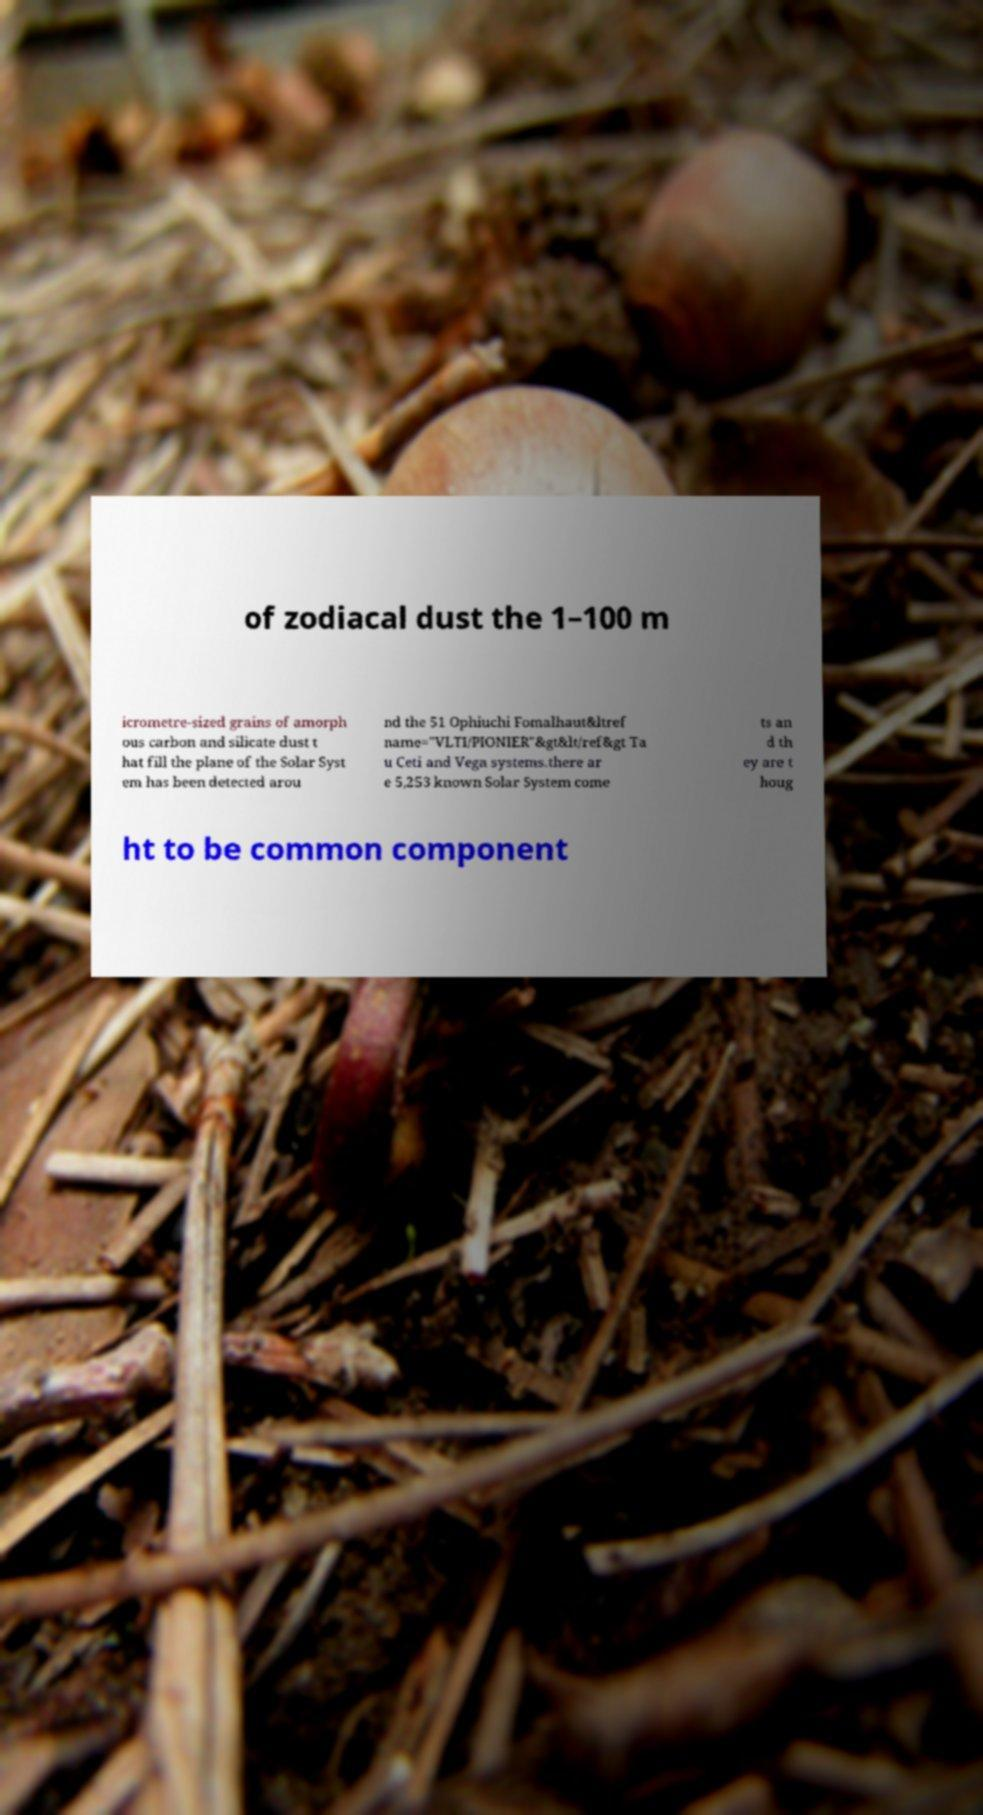Can you accurately transcribe the text from the provided image for me? of zodiacal dust the 1–100 m icrometre-sized grains of amorph ous carbon and silicate dust t hat fill the plane of the Solar Syst em has been detected arou nd the 51 Ophiuchi Fomalhaut&ltref name="VLTI/PIONIER"&gt&lt/ref&gt Ta u Ceti and Vega systems.there ar e 5,253 known Solar System come ts an d th ey are t houg ht to be common component 